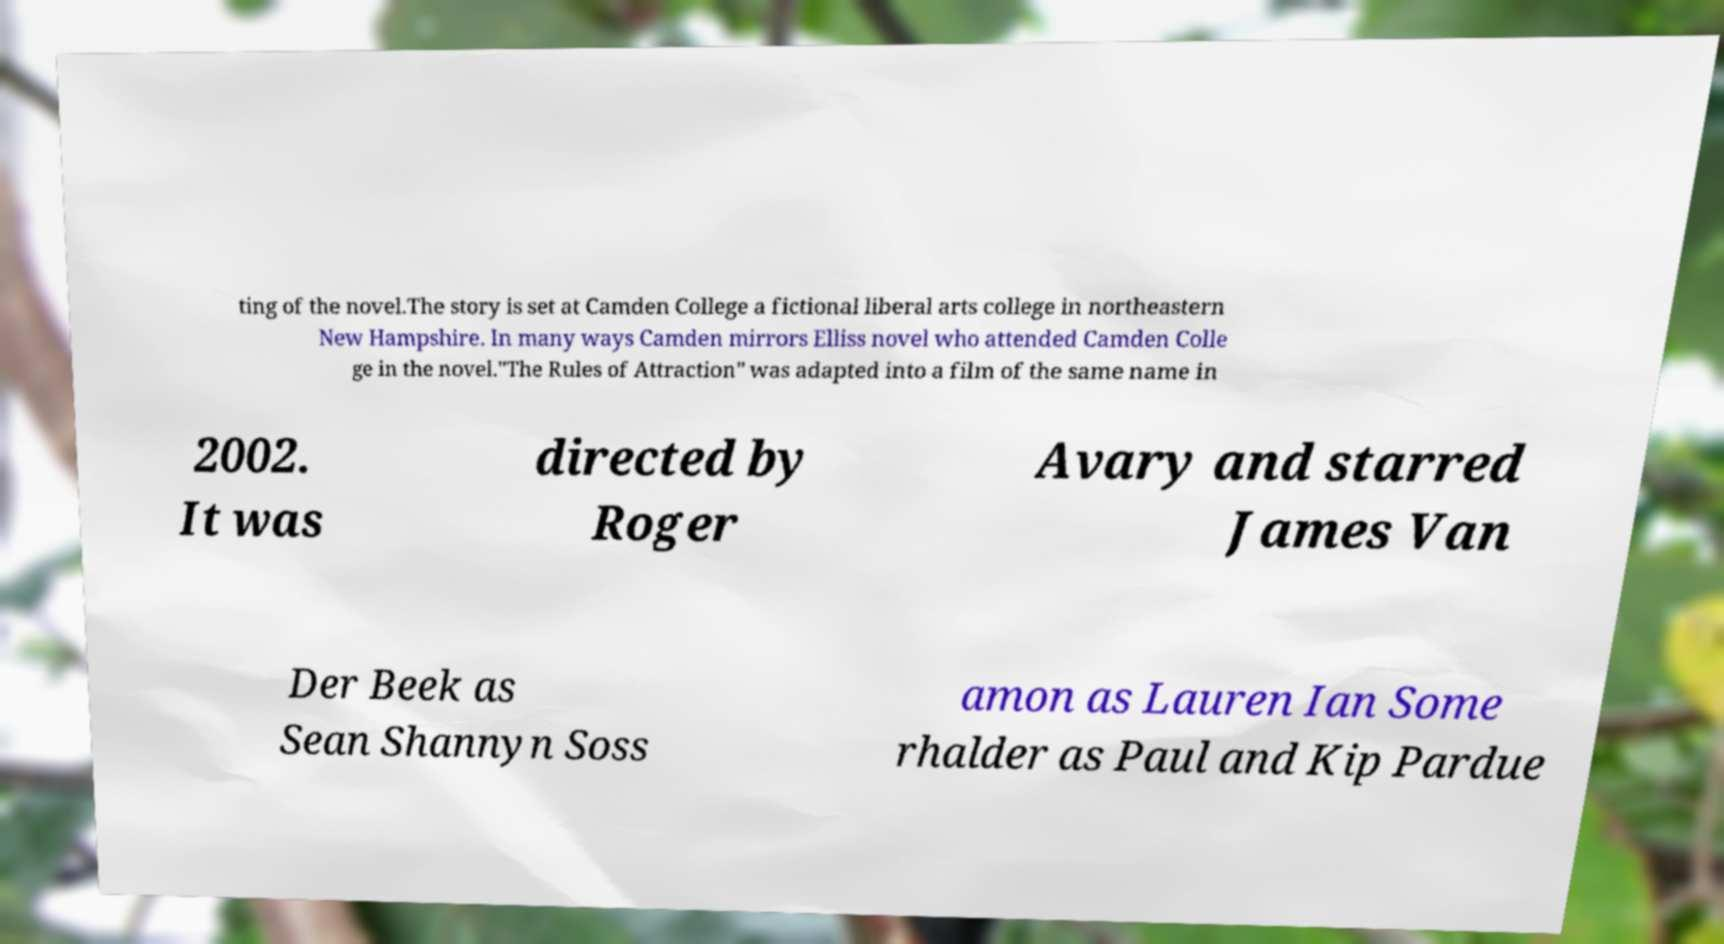Please read and relay the text visible in this image. What does it say? ting of the novel.The story is set at Camden College a fictional liberal arts college in northeastern New Hampshire. In many ways Camden mirrors Elliss novel who attended Camden Colle ge in the novel."The Rules of Attraction" was adapted into a film of the same name in 2002. It was directed by Roger Avary and starred James Van Der Beek as Sean Shannyn Soss amon as Lauren Ian Some rhalder as Paul and Kip Pardue 